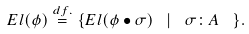<formula> <loc_0><loc_0><loc_500><loc_500>E l ( \phi ) \stackrel { d f . } { = } \{ E l ( \phi \bullet \sigma ) \ \, | \ \, \sigma \colon A \ \, \} .</formula> 